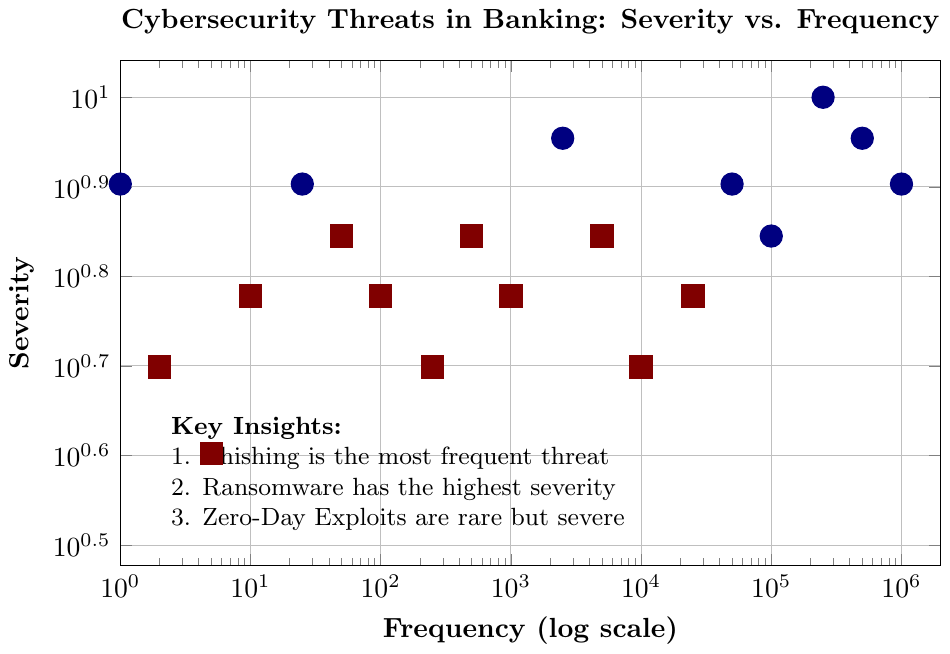Which threat has the highest severity? The plot indicates that 'Ransomware' has the highest severity with a value of 10.
Answer: Ransomware Which threats have a frequency greater than 100,000 and a severity greater than or equal to 8? From the plot, 'Phishing' (1,000,000, 8) and 'Malware' (500,000, 9) meet these criteria.
Answer: Phishing, Malware Compare the severity of 'Phishing' and 'Malware'. Which is higher? From the plot, 'Malware' has a severity of 9, while 'Phishing' has a severity of 8. Therefore, 'Malware' has a higher severity.
Answer: Malware Which threat is the least frequent but highly severe (severity >= 8)? Looking at the plot, 'Supply Chain Attacks' has the lowest frequency (1) but a high severity of 8.
Answer: Supply Chain Attacks What is the frequency range for threats with a severity of 7? The plot shows threats with a severity of 7 have frequencies ranging from 50 ('Mobile Malware') to 100,000 ('DDoS').
Answer: 50 to 100,000 What threat has a lower severity but much higher frequency than 'Zero-Day Exploits'? 'Phishing' has a lower severity (8) compared to 'Zero-Day Exploits' (9) but a much higher frequency (1,000,000 compared to 2,500).
Answer: Phishing Which threats are more frequent than 'Insider Threats' but have a lower severity? Threats with higher frequency than 'Insider Threats' (50,000, severity 8) but lower severity include 'Phishing', 'Malware', 'DDoS', 'SQL Injection', and 'Cross-Site Scripting'.
Answer: Phishing, Malware, DDoS, SQL Injection, Cross-Site Scripting Calculate the average severity of all threats with a frequency of 250 or below. The threats with frequencies of 250 or below are: 'API Vulnerabilities' (5), 'Cloud Misconfiguration' (6), 'Mobile Malware' (7), 'IoT Exploits' (8), 'ATM Skimming' (6), 'Cryptojacking' (4), 'Credential Stuffing' (5), and 'Supply Chain Attacks' (8). The average is (5 + 6 + 7 + 8 + 6 + 4 + 5 + 8) / 8 = 6.125
Answer: 6.125 What is the difference in severity between the most and least frequent threats? The most frequent threat is 'Phishing' with a severity of 8. The least frequent threat is 'Supply Chain Attacks' with a severity of 8. The difference in severity is 8 - 8 = 0.
Answer: 0 